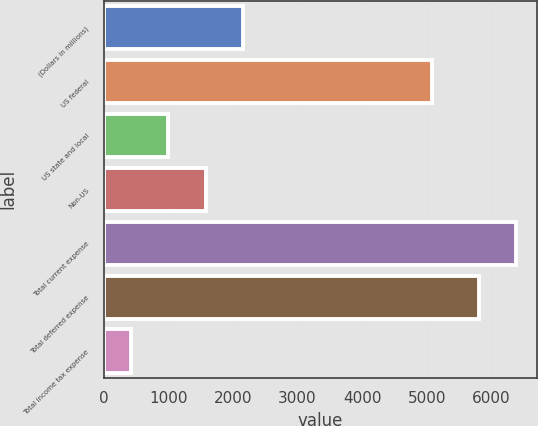<chart> <loc_0><loc_0><loc_500><loc_500><bar_chart><fcel>(Dollars in millions)<fcel>US federal<fcel>US state and local<fcel>Non-US<fcel>Total current expense<fcel>Total deferred expense<fcel>Total income tax expense<nl><fcel>2160.3<fcel>5075<fcel>1000.1<fcel>1580.2<fcel>6381.1<fcel>5801<fcel>420<nl></chart> 